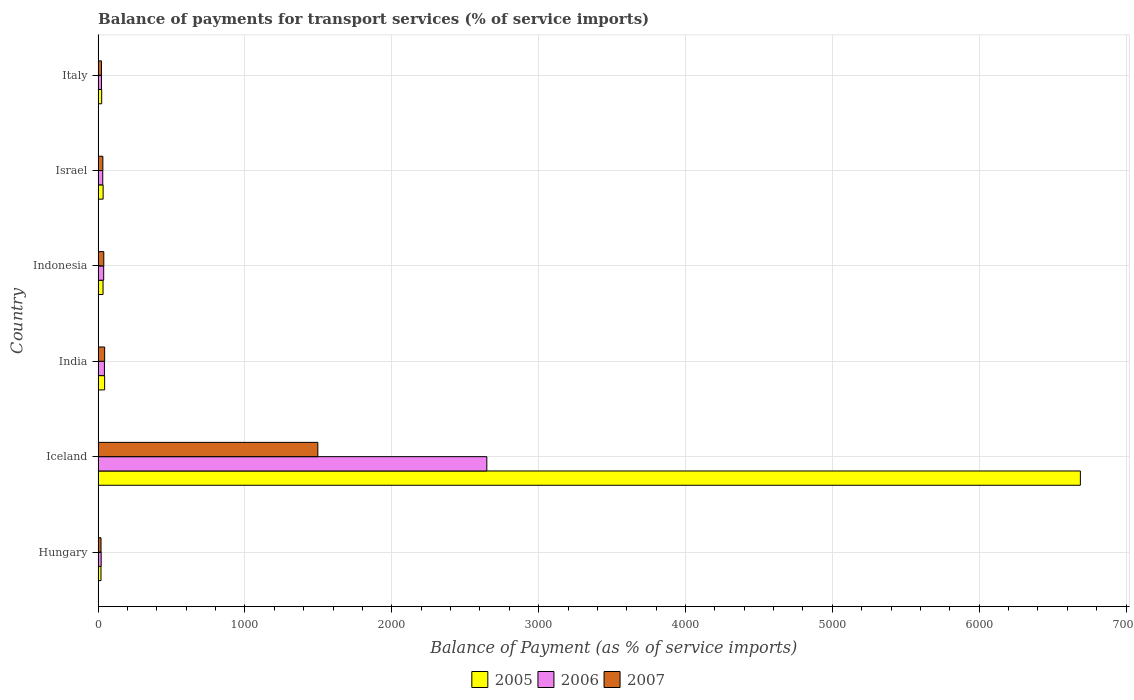How many groups of bars are there?
Provide a short and direct response. 6. What is the balance of payments for transport services in 2005 in Israel?
Your answer should be very brief. 34.07. Across all countries, what is the maximum balance of payments for transport services in 2006?
Provide a succinct answer. 2647.13. Across all countries, what is the minimum balance of payments for transport services in 2007?
Give a very brief answer. 19.77. In which country was the balance of payments for transport services in 2007 maximum?
Your answer should be compact. Iceland. In which country was the balance of payments for transport services in 2006 minimum?
Make the answer very short. Hungary. What is the total balance of payments for transport services in 2005 in the graph?
Your answer should be very brief. 6844.99. What is the difference between the balance of payments for transport services in 2005 in Indonesia and that in Italy?
Provide a short and direct response. 9.29. What is the difference between the balance of payments for transport services in 2006 in India and the balance of payments for transport services in 2007 in Indonesia?
Your response must be concise. 4.34. What is the average balance of payments for transport services in 2006 per country?
Your response must be concise. 467.22. What is the difference between the balance of payments for transport services in 2007 and balance of payments for transport services in 2005 in Indonesia?
Give a very brief answer. 5.09. In how many countries, is the balance of payments for transport services in 2005 greater than 6800 %?
Offer a terse response. 0. What is the ratio of the balance of payments for transport services in 2006 in Hungary to that in India?
Offer a terse response. 0.48. What is the difference between the highest and the second highest balance of payments for transport services in 2005?
Your answer should be very brief. 6644.87. What is the difference between the highest and the lowest balance of payments for transport services in 2006?
Offer a very short reply. 2626.32. What does the 1st bar from the top in Iceland represents?
Offer a terse response. 2007. How many bars are there?
Offer a terse response. 18. What is the difference between two consecutive major ticks on the X-axis?
Make the answer very short. 1000. Does the graph contain any zero values?
Your answer should be compact. No. How many legend labels are there?
Provide a succinct answer. 3. How are the legend labels stacked?
Your answer should be very brief. Horizontal. What is the title of the graph?
Offer a very short reply. Balance of payments for transport services (% of service imports). What is the label or title of the X-axis?
Your answer should be compact. Balance of Payment (as % of service imports). What is the label or title of the Y-axis?
Your answer should be very brief. Country. What is the Balance of Payment (as % of service imports) in 2005 in Hungary?
Your answer should be compact. 19.64. What is the Balance of Payment (as % of service imports) of 2006 in Hungary?
Provide a short and direct response. 20.81. What is the Balance of Payment (as % of service imports) in 2007 in Hungary?
Offer a very short reply. 19.77. What is the Balance of Payment (as % of service imports) of 2005 in Iceland?
Your response must be concise. 6689.16. What is the Balance of Payment (as % of service imports) in 2006 in Iceland?
Give a very brief answer. 2647.13. What is the Balance of Payment (as % of service imports) of 2007 in Iceland?
Your answer should be compact. 1496.22. What is the Balance of Payment (as % of service imports) in 2005 in India?
Provide a short and direct response. 44.28. What is the Balance of Payment (as % of service imports) of 2006 in India?
Offer a very short reply. 43. What is the Balance of Payment (as % of service imports) in 2007 in India?
Make the answer very short. 44.56. What is the Balance of Payment (as % of service imports) in 2005 in Indonesia?
Ensure brevity in your answer.  33.57. What is the Balance of Payment (as % of service imports) of 2006 in Indonesia?
Make the answer very short. 37.94. What is the Balance of Payment (as % of service imports) in 2007 in Indonesia?
Offer a terse response. 38.66. What is the Balance of Payment (as % of service imports) of 2005 in Israel?
Your answer should be very brief. 34.07. What is the Balance of Payment (as % of service imports) of 2006 in Israel?
Ensure brevity in your answer.  31.55. What is the Balance of Payment (as % of service imports) in 2007 in Israel?
Offer a very short reply. 32.27. What is the Balance of Payment (as % of service imports) of 2005 in Italy?
Your answer should be compact. 24.28. What is the Balance of Payment (as % of service imports) of 2006 in Italy?
Provide a short and direct response. 22.91. What is the Balance of Payment (as % of service imports) of 2007 in Italy?
Provide a succinct answer. 22.73. Across all countries, what is the maximum Balance of Payment (as % of service imports) in 2005?
Your answer should be very brief. 6689.16. Across all countries, what is the maximum Balance of Payment (as % of service imports) in 2006?
Offer a terse response. 2647.13. Across all countries, what is the maximum Balance of Payment (as % of service imports) in 2007?
Give a very brief answer. 1496.22. Across all countries, what is the minimum Balance of Payment (as % of service imports) in 2005?
Your answer should be very brief. 19.64. Across all countries, what is the minimum Balance of Payment (as % of service imports) of 2006?
Your response must be concise. 20.81. Across all countries, what is the minimum Balance of Payment (as % of service imports) in 2007?
Your response must be concise. 19.77. What is the total Balance of Payment (as % of service imports) of 2005 in the graph?
Give a very brief answer. 6844.99. What is the total Balance of Payment (as % of service imports) of 2006 in the graph?
Provide a short and direct response. 2803.34. What is the total Balance of Payment (as % of service imports) in 2007 in the graph?
Give a very brief answer. 1654.2. What is the difference between the Balance of Payment (as % of service imports) of 2005 in Hungary and that in Iceland?
Your answer should be compact. -6669.52. What is the difference between the Balance of Payment (as % of service imports) in 2006 in Hungary and that in Iceland?
Offer a very short reply. -2626.32. What is the difference between the Balance of Payment (as % of service imports) in 2007 in Hungary and that in Iceland?
Your answer should be very brief. -1476.45. What is the difference between the Balance of Payment (as % of service imports) in 2005 in Hungary and that in India?
Provide a short and direct response. -24.64. What is the difference between the Balance of Payment (as % of service imports) in 2006 in Hungary and that in India?
Ensure brevity in your answer.  -22.18. What is the difference between the Balance of Payment (as % of service imports) of 2007 in Hungary and that in India?
Give a very brief answer. -24.78. What is the difference between the Balance of Payment (as % of service imports) in 2005 in Hungary and that in Indonesia?
Keep it short and to the point. -13.93. What is the difference between the Balance of Payment (as % of service imports) in 2006 in Hungary and that in Indonesia?
Your response must be concise. -17.13. What is the difference between the Balance of Payment (as % of service imports) of 2007 in Hungary and that in Indonesia?
Offer a terse response. -18.88. What is the difference between the Balance of Payment (as % of service imports) of 2005 in Hungary and that in Israel?
Your answer should be very brief. -14.43. What is the difference between the Balance of Payment (as % of service imports) of 2006 in Hungary and that in Israel?
Offer a very short reply. -10.73. What is the difference between the Balance of Payment (as % of service imports) of 2007 in Hungary and that in Israel?
Your answer should be compact. -12.5. What is the difference between the Balance of Payment (as % of service imports) in 2005 in Hungary and that in Italy?
Offer a very short reply. -4.64. What is the difference between the Balance of Payment (as % of service imports) of 2006 in Hungary and that in Italy?
Provide a succinct answer. -2.1. What is the difference between the Balance of Payment (as % of service imports) in 2007 in Hungary and that in Italy?
Keep it short and to the point. -2.96. What is the difference between the Balance of Payment (as % of service imports) in 2005 in Iceland and that in India?
Offer a terse response. 6644.87. What is the difference between the Balance of Payment (as % of service imports) of 2006 in Iceland and that in India?
Offer a terse response. 2604.13. What is the difference between the Balance of Payment (as % of service imports) in 2007 in Iceland and that in India?
Give a very brief answer. 1451.67. What is the difference between the Balance of Payment (as % of service imports) of 2005 in Iceland and that in Indonesia?
Provide a short and direct response. 6655.59. What is the difference between the Balance of Payment (as % of service imports) in 2006 in Iceland and that in Indonesia?
Offer a very short reply. 2609.18. What is the difference between the Balance of Payment (as % of service imports) in 2007 in Iceland and that in Indonesia?
Your response must be concise. 1457.57. What is the difference between the Balance of Payment (as % of service imports) of 2005 in Iceland and that in Israel?
Your answer should be compact. 6655.08. What is the difference between the Balance of Payment (as % of service imports) in 2006 in Iceland and that in Israel?
Your response must be concise. 2615.58. What is the difference between the Balance of Payment (as % of service imports) of 2007 in Iceland and that in Israel?
Keep it short and to the point. 1463.95. What is the difference between the Balance of Payment (as % of service imports) of 2005 in Iceland and that in Italy?
Give a very brief answer. 6664.88. What is the difference between the Balance of Payment (as % of service imports) in 2006 in Iceland and that in Italy?
Keep it short and to the point. 2624.22. What is the difference between the Balance of Payment (as % of service imports) in 2007 in Iceland and that in Italy?
Make the answer very short. 1473.49. What is the difference between the Balance of Payment (as % of service imports) in 2005 in India and that in Indonesia?
Your answer should be compact. 10.72. What is the difference between the Balance of Payment (as % of service imports) of 2006 in India and that in Indonesia?
Provide a short and direct response. 5.05. What is the difference between the Balance of Payment (as % of service imports) of 2007 in India and that in Indonesia?
Ensure brevity in your answer.  5.9. What is the difference between the Balance of Payment (as % of service imports) of 2005 in India and that in Israel?
Keep it short and to the point. 10.21. What is the difference between the Balance of Payment (as % of service imports) of 2006 in India and that in Israel?
Provide a succinct answer. 11.45. What is the difference between the Balance of Payment (as % of service imports) in 2007 in India and that in Israel?
Offer a terse response. 12.29. What is the difference between the Balance of Payment (as % of service imports) in 2005 in India and that in Italy?
Your answer should be very brief. 20. What is the difference between the Balance of Payment (as % of service imports) in 2006 in India and that in Italy?
Your answer should be very brief. 20.08. What is the difference between the Balance of Payment (as % of service imports) of 2007 in India and that in Italy?
Your answer should be compact. 21.83. What is the difference between the Balance of Payment (as % of service imports) in 2005 in Indonesia and that in Israel?
Make the answer very short. -0.5. What is the difference between the Balance of Payment (as % of service imports) in 2006 in Indonesia and that in Israel?
Provide a short and direct response. 6.4. What is the difference between the Balance of Payment (as % of service imports) of 2007 in Indonesia and that in Israel?
Provide a succinct answer. 6.39. What is the difference between the Balance of Payment (as % of service imports) in 2005 in Indonesia and that in Italy?
Give a very brief answer. 9.29. What is the difference between the Balance of Payment (as % of service imports) of 2006 in Indonesia and that in Italy?
Ensure brevity in your answer.  15.03. What is the difference between the Balance of Payment (as % of service imports) of 2007 in Indonesia and that in Italy?
Your answer should be compact. 15.93. What is the difference between the Balance of Payment (as % of service imports) of 2005 in Israel and that in Italy?
Ensure brevity in your answer.  9.79. What is the difference between the Balance of Payment (as % of service imports) in 2006 in Israel and that in Italy?
Ensure brevity in your answer.  8.63. What is the difference between the Balance of Payment (as % of service imports) of 2007 in Israel and that in Italy?
Make the answer very short. 9.54. What is the difference between the Balance of Payment (as % of service imports) in 2005 in Hungary and the Balance of Payment (as % of service imports) in 2006 in Iceland?
Your answer should be very brief. -2627.49. What is the difference between the Balance of Payment (as % of service imports) in 2005 in Hungary and the Balance of Payment (as % of service imports) in 2007 in Iceland?
Offer a terse response. -1476.58. What is the difference between the Balance of Payment (as % of service imports) of 2006 in Hungary and the Balance of Payment (as % of service imports) of 2007 in Iceland?
Make the answer very short. -1475.41. What is the difference between the Balance of Payment (as % of service imports) in 2005 in Hungary and the Balance of Payment (as % of service imports) in 2006 in India?
Offer a very short reply. -23.36. What is the difference between the Balance of Payment (as % of service imports) in 2005 in Hungary and the Balance of Payment (as % of service imports) in 2007 in India?
Give a very brief answer. -24.92. What is the difference between the Balance of Payment (as % of service imports) in 2006 in Hungary and the Balance of Payment (as % of service imports) in 2007 in India?
Give a very brief answer. -23.74. What is the difference between the Balance of Payment (as % of service imports) of 2005 in Hungary and the Balance of Payment (as % of service imports) of 2006 in Indonesia?
Offer a terse response. -18.3. What is the difference between the Balance of Payment (as % of service imports) in 2005 in Hungary and the Balance of Payment (as % of service imports) in 2007 in Indonesia?
Give a very brief answer. -19.02. What is the difference between the Balance of Payment (as % of service imports) in 2006 in Hungary and the Balance of Payment (as % of service imports) in 2007 in Indonesia?
Offer a very short reply. -17.84. What is the difference between the Balance of Payment (as % of service imports) in 2005 in Hungary and the Balance of Payment (as % of service imports) in 2006 in Israel?
Ensure brevity in your answer.  -11.91. What is the difference between the Balance of Payment (as % of service imports) of 2005 in Hungary and the Balance of Payment (as % of service imports) of 2007 in Israel?
Make the answer very short. -12.63. What is the difference between the Balance of Payment (as % of service imports) in 2006 in Hungary and the Balance of Payment (as % of service imports) in 2007 in Israel?
Your answer should be compact. -11.46. What is the difference between the Balance of Payment (as % of service imports) in 2005 in Hungary and the Balance of Payment (as % of service imports) in 2006 in Italy?
Offer a very short reply. -3.27. What is the difference between the Balance of Payment (as % of service imports) in 2005 in Hungary and the Balance of Payment (as % of service imports) in 2007 in Italy?
Give a very brief answer. -3.09. What is the difference between the Balance of Payment (as % of service imports) in 2006 in Hungary and the Balance of Payment (as % of service imports) in 2007 in Italy?
Offer a very short reply. -1.92. What is the difference between the Balance of Payment (as % of service imports) in 2005 in Iceland and the Balance of Payment (as % of service imports) in 2006 in India?
Give a very brief answer. 6646.16. What is the difference between the Balance of Payment (as % of service imports) of 2005 in Iceland and the Balance of Payment (as % of service imports) of 2007 in India?
Provide a short and direct response. 6644.6. What is the difference between the Balance of Payment (as % of service imports) of 2006 in Iceland and the Balance of Payment (as % of service imports) of 2007 in India?
Ensure brevity in your answer.  2602.57. What is the difference between the Balance of Payment (as % of service imports) in 2005 in Iceland and the Balance of Payment (as % of service imports) in 2006 in Indonesia?
Your response must be concise. 6651.21. What is the difference between the Balance of Payment (as % of service imports) of 2005 in Iceland and the Balance of Payment (as % of service imports) of 2007 in Indonesia?
Offer a very short reply. 6650.5. What is the difference between the Balance of Payment (as % of service imports) of 2006 in Iceland and the Balance of Payment (as % of service imports) of 2007 in Indonesia?
Your answer should be very brief. 2608.47. What is the difference between the Balance of Payment (as % of service imports) in 2005 in Iceland and the Balance of Payment (as % of service imports) in 2006 in Israel?
Keep it short and to the point. 6657.61. What is the difference between the Balance of Payment (as % of service imports) in 2005 in Iceland and the Balance of Payment (as % of service imports) in 2007 in Israel?
Offer a terse response. 6656.89. What is the difference between the Balance of Payment (as % of service imports) in 2006 in Iceland and the Balance of Payment (as % of service imports) in 2007 in Israel?
Your response must be concise. 2614.86. What is the difference between the Balance of Payment (as % of service imports) of 2005 in Iceland and the Balance of Payment (as % of service imports) of 2006 in Italy?
Make the answer very short. 6666.24. What is the difference between the Balance of Payment (as % of service imports) in 2005 in Iceland and the Balance of Payment (as % of service imports) in 2007 in Italy?
Offer a very short reply. 6666.43. What is the difference between the Balance of Payment (as % of service imports) of 2006 in Iceland and the Balance of Payment (as % of service imports) of 2007 in Italy?
Keep it short and to the point. 2624.4. What is the difference between the Balance of Payment (as % of service imports) of 2005 in India and the Balance of Payment (as % of service imports) of 2006 in Indonesia?
Ensure brevity in your answer.  6.34. What is the difference between the Balance of Payment (as % of service imports) of 2005 in India and the Balance of Payment (as % of service imports) of 2007 in Indonesia?
Keep it short and to the point. 5.63. What is the difference between the Balance of Payment (as % of service imports) in 2006 in India and the Balance of Payment (as % of service imports) in 2007 in Indonesia?
Offer a terse response. 4.34. What is the difference between the Balance of Payment (as % of service imports) of 2005 in India and the Balance of Payment (as % of service imports) of 2006 in Israel?
Keep it short and to the point. 12.74. What is the difference between the Balance of Payment (as % of service imports) in 2005 in India and the Balance of Payment (as % of service imports) in 2007 in Israel?
Keep it short and to the point. 12.01. What is the difference between the Balance of Payment (as % of service imports) in 2006 in India and the Balance of Payment (as % of service imports) in 2007 in Israel?
Make the answer very short. 10.73. What is the difference between the Balance of Payment (as % of service imports) of 2005 in India and the Balance of Payment (as % of service imports) of 2006 in Italy?
Ensure brevity in your answer.  21.37. What is the difference between the Balance of Payment (as % of service imports) in 2005 in India and the Balance of Payment (as % of service imports) in 2007 in Italy?
Provide a succinct answer. 21.55. What is the difference between the Balance of Payment (as % of service imports) of 2006 in India and the Balance of Payment (as % of service imports) of 2007 in Italy?
Provide a succinct answer. 20.27. What is the difference between the Balance of Payment (as % of service imports) of 2005 in Indonesia and the Balance of Payment (as % of service imports) of 2006 in Israel?
Provide a succinct answer. 2.02. What is the difference between the Balance of Payment (as % of service imports) of 2005 in Indonesia and the Balance of Payment (as % of service imports) of 2007 in Israel?
Give a very brief answer. 1.3. What is the difference between the Balance of Payment (as % of service imports) in 2006 in Indonesia and the Balance of Payment (as % of service imports) in 2007 in Israel?
Give a very brief answer. 5.67. What is the difference between the Balance of Payment (as % of service imports) of 2005 in Indonesia and the Balance of Payment (as % of service imports) of 2006 in Italy?
Ensure brevity in your answer.  10.65. What is the difference between the Balance of Payment (as % of service imports) of 2005 in Indonesia and the Balance of Payment (as % of service imports) of 2007 in Italy?
Offer a terse response. 10.84. What is the difference between the Balance of Payment (as % of service imports) of 2006 in Indonesia and the Balance of Payment (as % of service imports) of 2007 in Italy?
Offer a terse response. 15.21. What is the difference between the Balance of Payment (as % of service imports) of 2005 in Israel and the Balance of Payment (as % of service imports) of 2006 in Italy?
Provide a short and direct response. 11.16. What is the difference between the Balance of Payment (as % of service imports) in 2005 in Israel and the Balance of Payment (as % of service imports) in 2007 in Italy?
Give a very brief answer. 11.34. What is the difference between the Balance of Payment (as % of service imports) in 2006 in Israel and the Balance of Payment (as % of service imports) in 2007 in Italy?
Your answer should be compact. 8.81. What is the average Balance of Payment (as % of service imports) in 2005 per country?
Keep it short and to the point. 1140.83. What is the average Balance of Payment (as % of service imports) in 2006 per country?
Ensure brevity in your answer.  467.22. What is the average Balance of Payment (as % of service imports) of 2007 per country?
Your answer should be compact. 275.7. What is the difference between the Balance of Payment (as % of service imports) in 2005 and Balance of Payment (as % of service imports) in 2006 in Hungary?
Offer a very short reply. -1.17. What is the difference between the Balance of Payment (as % of service imports) of 2005 and Balance of Payment (as % of service imports) of 2007 in Hungary?
Ensure brevity in your answer.  -0.13. What is the difference between the Balance of Payment (as % of service imports) in 2006 and Balance of Payment (as % of service imports) in 2007 in Hungary?
Your response must be concise. 1.04. What is the difference between the Balance of Payment (as % of service imports) in 2005 and Balance of Payment (as % of service imports) in 2006 in Iceland?
Give a very brief answer. 4042.03. What is the difference between the Balance of Payment (as % of service imports) in 2005 and Balance of Payment (as % of service imports) in 2007 in Iceland?
Provide a short and direct response. 5192.93. What is the difference between the Balance of Payment (as % of service imports) of 2006 and Balance of Payment (as % of service imports) of 2007 in Iceland?
Provide a succinct answer. 1150.91. What is the difference between the Balance of Payment (as % of service imports) of 2005 and Balance of Payment (as % of service imports) of 2006 in India?
Give a very brief answer. 1.29. What is the difference between the Balance of Payment (as % of service imports) in 2005 and Balance of Payment (as % of service imports) in 2007 in India?
Provide a succinct answer. -0.27. What is the difference between the Balance of Payment (as % of service imports) of 2006 and Balance of Payment (as % of service imports) of 2007 in India?
Give a very brief answer. -1.56. What is the difference between the Balance of Payment (as % of service imports) of 2005 and Balance of Payment (as % of service imports) of 2006 in Indonesia?
Ensure brevity in your answer.  -4.38. What is the difference between the Balance of Payment (as % of service imports) in 2005 and Balance of Payment (as % of service imports) in 2007 in Indonesia?
Your response must be concise. -5.09. What is the difference between the Balance of Payment (as % of service imports) of 2006 and Balance of Payment (as % of service imports) of 2007 in Indonesia?
Give a very brief answer. -0.71. What is the difference between the Balance of Payment (as % of service imports) in 2005 and Balance of Payment (as % of service imports) in 2006 in Israel?
Provide a short and direct response. 2.53. What is the difference between the Balance of Payment (as % of service imports) in 2005 and Balance of Payment (as % of service imports) in 2007 in Israel?
Offer a very short reply. 1.8. What is the difference between the Balance of Payment (as % of service imports) in 2006 and Balance of Payment (as % of service imports) in 2007 in Israel?
Give a very brief answer. -0.72. What is the difference between the Balance of Payment (as % of service imports) in 2005 and Balance of Payment (as % of service imports) in 2006 in Italy?
Your answer should be very brief. 1.37. What is the difference between the Balance of Payment (as % of service imports) in 2005 and Balance of Payment (as % of service imports) in 2007 in Italy?
Offer a very short reply. 1.55. What is the difference between the Balance of Payment (as % of service imports) in 2006 and Balance of Payment (as % of service imports) in 2007 in Italy?
Your answer should be very brief. 0.18. What is the ratio of the Balance of Payment (as % of service imports) in 2005 in Hungary to that in Iceland?
Give a very brief answer. 0. What is the ratio of the Balance of Payment (as % of service imports) of 2006 in Hungary to that in Iceland?
Keep it short and to the point. 0.01. What is the ratio of the Balance of Payment (as % of service imports) in 2007 in Hungary to that in Iceland?
Provide a short and direct response. 0.01. What is the ratio of the Balance of Payment (as % of service imports) of 2005 in Hungary to that in India?
Your response must be concise. 0.44. What is the ratio of the Balance of Payment (as % of service imports) in 2006 in Hungary to that in India?
Your response must be concise. 0.48. What is the ratio of the Balance of Payment (as % of service imports) of 2007 in Hungary to that in India?
Provide a succinct answer. 0.44. What is the ratio of the Balance of Payment (as % of service imports) of 2005 in Hungary to that in Indonesia?
Ensure brevity in your answer.  0.59. What is the ratio of the Balance of Payment (as % of service imports) in 2006 in Hungary to that in Indonesia?
Provide a short and direct response. 0.55. What is the ratio of the Balance of Payment (as % of service imports) of 2007 in Hungary to that in Indonesia?
Ensure brevity in your answer.  0.51. What is the ratio of the Balance of Payment (as % of service imports) of 2005 in Hungary to that in Israel?
Make the answer very short. 0.58. What is the ratio of the Balance of Payment (as % of service imports) of 2006 in Hungary to that in Israel?
Provide a succinct answer. 0.66. What is the ratio of the Balance of Payment (as % of service imports) of 2007 in Hungary to that in Israel?
Provide a succinct answer. 0.61. What is the ratio of the Balance of Payment (as % of service imports) of 2005 in Hungary to that in Italy?
Offer a very short reply. 0.81. What is the ratio of the Balance of Payment (as % of service imports) of 2006 in Hungary to that in Italy?
Your response must be concise. 0.91. What is the ratio of the Balance of Payment (as % of service imports) in 2007 in Hungary to that in Italy?
Provide a succinct answer. 0.87. What is the ratio of the Balance of Payment (as % of service imports) in 2005 in Iceland to that in India?
Offer a terse response. 151.06. What is the ratio of the Balance of Payment (as % of service imports) of 2006 in Iceland to that in India?
Offer a very short reply. 61.57. What is the ratio of the Balance of Payment (as % of service imports) of 2007 in Iceland to that in India?
Ensure brevity in your answer.  33.58. What is the ratio of the Balance of Payment (as % of service imports) of 2005 in Iceland to that in Indonesia?
Offer a very short reply. 199.28. What is the ratio of the Balance of Payment (as % of service imports) of 2006 in Iceland to that in Indonesia?
Your answer should be compact. 69.77. What is the ratio of the Balance of Payment (as % of service imports) in 2007 in Iceland to that in Indonesia?
Provide a succinct answer. 38.71. What is the ratio of the Balance of Payment (as % of service imports) of 2005 in Iceland to that in Israel?
Ensure brevity in your answer.  196.33. What is the ratio of the Balance of Payment (as % of service imports) in 2006 in Iceland to that in Israel?
Make the answer very short. 83.92. What is the ratio of the Balance of Payment (as % of service imports) in 2007 in Iceland to that in Israel?
Your answer should be compact. 46.37. What is the ratio of the Balance of Payment (as % of service imports) of 2005 in Iceland to that in Italy?
Your answer should be compact. 275.52. What is the ratio of the Balance of Payment (as % of service imports) in 2006 in Iceland to that in Italy?
Provide a succinct answer. 115.53. What is the ratio of the Balance of Payment (as % of service imports) in 2007 in Iceland to that in Italy?
Ensure brevity in your answer.  65.83. What is the ratio of the Balance of Payment (as % of service imports) of 2005 in India to that in Indonesia?
Provide a succinct answer. 1.32. What is the ratio of the Balance of Payment (as % of service imports) of 2006 in India to that in Indonesia?
Your response must be concise. 1.13. What is the ratio of the Balance of Payment (as % of service imports) of 2007 in India to that in Indonesia?
Offer a terse response. 1.15. What is the ratio of the Balance of Payment (as % of service imports) of 2005 in India to that in Israel?
Your answer should be compact. 1.3. What is the ratio of the Balance of Payment (as % of service imports) of 2006 in India to that in Israel?
Give a very brief answer. 1.36. What is the ratio of the Balance of Payment (as % of service imports) in 2007 in India to that in Israel?
Your answer should be compact. 1.38. What is the ratio of the Balance of Payment (as % of service imports) of 2005 in India to that in Italy?
Give a very brief answer. 1.82. What is the ratio of the Balance of Payment (as % of service imports) in 2006 in India to that in Italy?
Your answer should be very brief. 1.88. What is the ratio of the Balance of Payment (as % of service imports) of 2007 in India to that in Italy?
Your response must be concise. 1.96. What is the ratio of the Balance of Payment (as % of service imports) in 2005 in Indonesia to that in Israel?
Ensure brevity in your answer.  0.99. What is the ratio of the Balance of Payment (as % of service imports) of 2006 in Indonesia to that in Israel?
Provide a short and direct response. 1.2. What is the ratio of the Balance of Payment (as % of service imports) in 2007 in Indonesia to that in Israel?
Ensure brevity in your answer.  1.2. What is the ratio of the Balance of Payment (as % of service imports) of 2005 in Indonesia to that in Italy?
Your answer should be compact. 1.38. What is the ratio of the Balance of Payment (as % of service imports) in 2006 in Indonesia to that in Italy?
Provide a short and direct response. 1.66. What is the ratio of the Balance of Payment (as % of service imports) in 2007 in Indonesia to that in Italy?
Keep it short and to the point. 1.7. What is the ratio of the Balance of Payment (as % of service imports) of 2005 in Israel to that in Italy?
Ensure brevity in your answer.  1.4. What is the ratio of the Balance of Payment (as % of service imports) of 2006 in Israel to that in Italy?
Keep it short and to the point. 1.38. What is the ratio of the Balance of Payment (as % of service imports) in 2007 in Israel to that in Italy?
Provide a succinct answer. 1.42. What is the difference between the highest and the second highest Balance of Payment (as % of service imports) of 2005?
Ensure brevity in your answer.  6644.87. What is the difference between the highest and the second highest Balance of Payment (as % of service imports) in 2006?
Provide a succinct answer. 2604.13. What is the difference between the highest and the second highest Balance of Payment (as % of service imports) in 2007?
Offer a terse response. 1451.67. What is the difference between the highest and the lowest Balance of Payment (as % of service imports) of 2005?
Offer a terse response. 6669.52. What is the difference between the highest and the lowest Balance of Payment (as % of service imports) of 2006?
Your answer should be compact. 2626.32. What is the difference between the highest and the lowest Balance of Payment (as % of service imports) of 2007?
Offer a very short reply. 1476.45. 